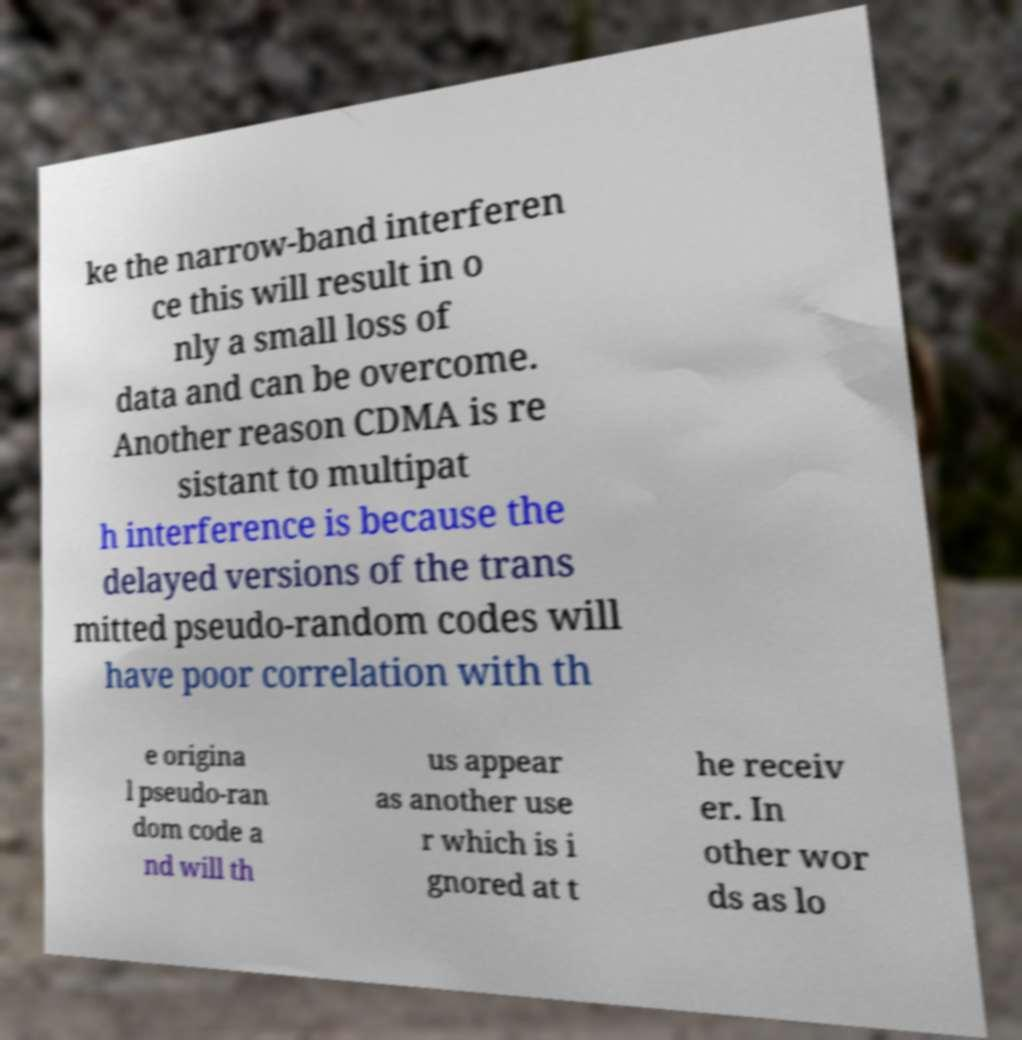What messages or text are displayed in this image? I need them in a readable, typed format. ke the narrow-band interferen ce this will result in o nly a small loss of data and can be overcome. Another reason CDMA is re sistant to multipat h interference is because the delayed versions of the trans mitted pseudo-random codes will have poor correlation with th e origina l pseudo-ran dom code a nd will th us appear as another use r which is i gnored at t he receiv er. In other wor ds as lo 